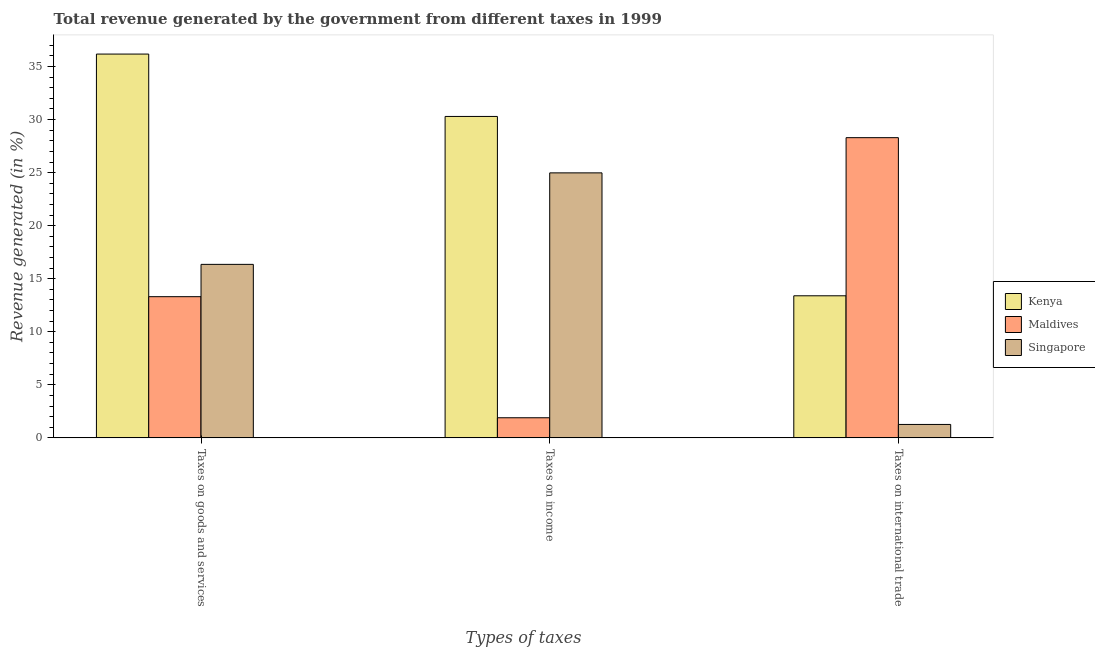How many different coloured bars are there?
Give a very brief answer. 3. Are the number of bars on each tick of the X-axis equal?
Provide a succinct answer. Yes. What is the label of the 2nd group of bars from the left?
Offer a terse response. Taxes on income. What is the percentage of revenue generated by taxes on goods and services in Maldives?
Give a very brief answer. 13.31. Across all countries, what is the maximum percentage of revenue generated by tax on international trade?
Make the answer very short. 28.29. Across all countries, what is the minimum percentage of revenue generated by tax on international trade?
Offer a very short reply. 1.26. In which country was the percentage of revenue generated by tax on international trade maximum?
Make the answer very short. Maldives. In which country was the percentage of revenue generated by taxes on goods and services minimum?
Your response must be concise. Maldives. What is the total percentage of revenue generated by tax on international trade in the graph?
Provide a short and direct response. 42.95. What is the difference between the percentage of revenue generated by tax on international trade in Kenya and that in Singapore?
Provide a succinct answer. 12.13. What is the difference between the percentage of revenue generated by taxes on goods and services in Maldives and the percentage of revenue generated by taxes on income in Kenya?
Provide a short and direct response. -16.99. What is the average percentage of revenue generated by tax on international trade per country?
Ensure brevity in your answer.  14.32. What is the difference between the percentage of revenue generated by taxes on income and percentage of revenue generated by taxes on goods and services in Singapore?
Provide a succinct answer. 8.62. In how many countries, is the percentage of revenue generated by taxes on income greater than 34 %?
Your answer should be very brief. 0. What is the ratio of the percentage of revenue generated by tax on international trade in Singapore to that in Maldives?
Offer a very short reply. 0.04. What is the difference between the highest and the second highest percentage of revenue generated by taxes on income?
Your response must be concise. 5.32. What is the difference between the highest and the lowest percentage of revenue generated by taxes on income?
Your answer should be compact. 28.4. In how many countries, is the percentage of revenue generated by tax on international trade greater than the average percentage of revenue generated by tax on international trade taken over all countries?
Give a very brief answer. 1. What does the 2nd bar from the left in Taxes on income represents?
Ensure brevity in your answer.  Maldives. What does the 1st bar from the right in Taxes on goods and services represents?
Provide a succinct answer. Singapore. Are all the bars in the graph horizontal?
Ensure brevity in your answer.  No. How many countries are there in the graph?
Ensure brevity in your answer.  3. Does the graph contain any zero values?
Give a very brief answer. No. Does the graph contain grids?
Provide a short and direct response. No. How many legend labels are there?
Your response must be concise. 3. What is the title of the graph?
Offer a very short reply. Total revenue generated by the government from different taxes in 1999. What is the label or title of the X-axis?
Keep it short and to the point. Types of taxes. What is the label or title of the Y-axis?
Your response must be concise. Revenue generated (in %). What is the Revenue generated (in %) in Kenya in Taxes on goods and services?
Offer a terse response. 36.17. What is the Revenue generated (in %) of Maldives in Taxes on goods and services?
Provide a short and direct response. 13.31. What is the Revenue generated (in %) of Singapore in Taxes on goods and services?
Ensure brevity in your answer.  16.35. What is the Revenue generated (in %) of Kenya in Taxes on income?
Provide a succinct answer. 30.29. What is the Revenue generated (in %) of Maldives in Taxes on income?
Make the answer very short. 1.9. What is the Revenue generated (in %) in Singapore in Taxes on income?
Provide a succinct answer. 24.98. What is the Revenue generated (in %) of Kenya in Taxes on international trade?
Your answer should be very brief. 13.39. What is the Revenue generated (in %) in Maldives in Taxes on international trade?
Provide a succinct answer. 28.29. What is the Revenue generated (in %) in Singapore in Taxes on international trade?
Give a very brief answer. 1.26. Across all Types of taxes, what is the maximum Revenue generated (in %) of Kenya?
Your response must be concise. 36.17. Across all Types of taxes, what is the maximum Revenue generated (in %) of Maldives?
Your answer should be very brief. 28.29. Across all Types of taxes, what is the maximum Revenue generated (in %) in Singapore?
Your response must be concise. 24.98. Across all Types of taxes, what is the minimum Revenue generated (in %) in Kenya?
Ensure brevity in your answer.  13.39. Across all Types of taxes, what is the minimum Revenue generated (in %) of Maldives?
Offer a terse response. 1.9. Across all Types of taxes, what is the minimum Revenue generated (in %) in Singapore?
Offer a very short reply. 1.26. What is the total Revenue generated (in %) of Kenya in the graph?
Keep it short and to the point. 79.86. What is the total Revenue generated (in %) of Maldives in the graph?
Your answer should be very brief. 43.5. What is the total Revenue generated (in %) in Singapore in the graph?
Offer a terse response. 42.59. What is the difference between the Revenue generated (in %) of Kenya in Taxes on goods and services and that in Taxes on income?
Offer a terse response. 5.88. What is the difference between the Revenue generated (in %) in Maldives in Taxes on goods and services and that in Taxes on income?
Provide a short and direct response. 11.41. What is the difference between the Revenue generated (in %) of Singapore in Taxes on goods and services and that in Taxes on income?
Ensure brevity in your answer.  -8.62. What is the difference between the Revenue generated (in %) in Kenya in Taxes on goods and services and that in Taxes on international trade?
Ensure brevity in your answer.  22.78. What is the difference between the Revenue generated (in %) of Maldives in Taxes on goods and services and that in Taxes on international trade?
Provide a short and direct response. -14.99. What is the difference between the Revenue generated (in %) of Singapore in Taxes on goods and services and that in Taxes on international trade?
Keep it short and to the point. 15.09. What is the difference between the Revenue generated (in %) in Kenya in Taxes on income and that in Taxes on international trade?
Offer a very short reply. 16.9. What is the difference between the Revenue generated (in %) in Maldives in Taxes on income and that in Taxes on international trade?
Keep it short and to the point. -26.4. What is the difference between the Revenue generated (in %) of Singapore in Taxes on income and that in Taxes on international trade?
Your answer should be compact. 23.71. What is the difference between the Revenue generated (in %) of Kenya in Taxes on goods and services and the Revenue generated (in %) of Maldives in Taxes on income?
Your response must be concise. 34.28. What is the difference between the Revenue generated (in %) in Kenya in Taxes on goods and services and the Revenue generated (in %) in Singapore in Taxes on income?
Provide a short and direct response. 11.2. What is the difference between the Revenue generated (in %) of Maldives in Taxes on goods and services and the Revenue generated (in %) of Singapore in Taxes on income?
Offer a terse response. -11.67. What is the difference between the Revenue generated (in %) in Kenya in Taxes on goods and services and the Revenue generated (in %) in Maldives in Taxes on international trade?
Your response must be concise. 7.88. What is the difference between the Revenue generated (in %) of Kenya in Taxes on goods and services and the Revenue generated (in %) of Singapore in Taxes on international trade?
Ensure brevity in your answer.  34.91. What is the difference between the Revenue generated (in %) of Maldives in Taxes on goods and services and the Revenue generated (in %) of Singapore in Taxes on international trade?
Keep it short and to the point. 12.04. What is the difference between the Revenue generated (in %) of Kenya in Taxes on income and the Revenue generated (in %) of Maldives in Taxes on international trade?
Provide a succinct answer. 2. What is the difference between the Revenue generated (in %) in Kenya in Taxes on income and the Revenue generated (in %) in Singapore in Taxes on international trade?
Give a very brief answer. 29.03. What is the difference between the Revenue generated (in %) of Maldives in Taxes on income and the Revenue generated (in %) of Singapore in Taxes on international trade?
Keep it short and to the point. 0.63. What is the average Revenue generated (in %) in Kenya per Types of taxes?
Your response must be concise. 26.62. What is the average Revenue generated (in %) of Maldives per Types of taxes?
Your response must be concise. 14.5. What is the average Revenue generated (in %) of Singapore per Types of taxes?
Keep it short and to the point. 14.2. What is the difference between the Revenue generated (in %) of Kenya and Revenue generated (in %) of Maldives in Taxes on goods and services?
Provide a short and direct response. 22.87. What is the difference between the Revenue generated (in %) of Kenya and Revenue generated (in %) of Singapore in Taxes on goods and services?
Provide a succinct answer. 19.82. What is the difference between the Revenue generated (in %) of Maldives and Revenue generated (in %) of Singapore in Taxes on goods and services?
Make the answer very short. -3.05. What is the difference between the Revenue generated (in %) in Kenya and Revenue generated (in %) in Maldives in Taxes on income?
Offer a very short reply. 28.4. What is the difference between the Revenue generated (in %) in Kenya and Revenue generated (in %) in Singapore in Taxes on income?
Give a very brief answer. 5.32. What is the difference between the Revenue generated (in %) in Maldives and Revenue generated (in %) in Singapore in Taxes on income?
Provide a succinct answer. -23.08. What is the difference between the Revenue generated (in %) of Kenya and Revenue generated (in %) of Maldives in Taxes on international trade?
Ensure brevity in your answer.  -14.9. What is the difference between the Revenue generated (in %) of Kenya and Revenue generated (in %) of Singapore in Taxes on international trade?
Keep it short and to the point. 12.13. What is the difference between the Revenue generated (in %) of Maldives and Revenue generated (in %) of Singapore in Taxes on international trade?
Keep it short and to the point. 27.03. What is the ratio of the Revenue generated (in %) of Kenya in Taxes on goods and services to that in Taxes on income?
Provide a short and direct response. 1.19. What is the ratio of the Revenue generated (in %) of Maldives in Taxes on goods and services to that in Taxes on income?
Offer a terse response. 7.02. What is the ratio of the Revenue generated (in %) of Singapore in Taxes on goods and services to that in Taxes on income?
Give a very brief answer. 0.65. What is the ratio of the Revenue generated (in %) in Kenya in Taxes on goods and services to that in Taxes on international trade?
Your answer should be compact. 2.7. What is the ratio of the Revenue generated (in %) of Maldives in Taxes on goods and services to that in Taxes on international trade?
Offer a terse response. 0.47. What is the ratio of the Revenue generated (in %) of Singapore in Taxes on goods and services to that in Taxes on international trade?
Your answer should be compact. 12.93. What is the ratio of the Revenue generated (in %) of Kenya in Taxes on income to that in Taxes on international trade?
Give a very brief answer. 2.26. What is the ratio of the Revenue generated (in %) of Maldives in Taxes on income to that in Taxes on international trade?
Provide a succinct answer. 0.07. What is the ratio of the Revenue generated (in %) in Singapore in Taxes on income to that in Taxes on international trade?
Keep it short and to the point. 19.75. What is the difference between the highest and the second highest Revenue generated (in %) in Kenya?
Your response must be concise. 5.88. What is the difference between the highest and the second highest Revenue generated (in %) of Maldives?
Your answer should be very brief. 14.99. What is the difference between the highest and the second highest Revenue generated (in %) of Singapore?
Ensure brevity in your answer.  8.62. What is the difference between the highest and the lowest Revenue generated (in %) in Kenya?
Give a very brief answer. 22.78. What is the difference between the highest and the lowest Revenue generated (in %) of Maldives?
Your response must be concise. 26.4. What is the difference between the highest and the lowest Revenue generated (in %) of Singapore?
Your answer should be very brief. 23.71. 